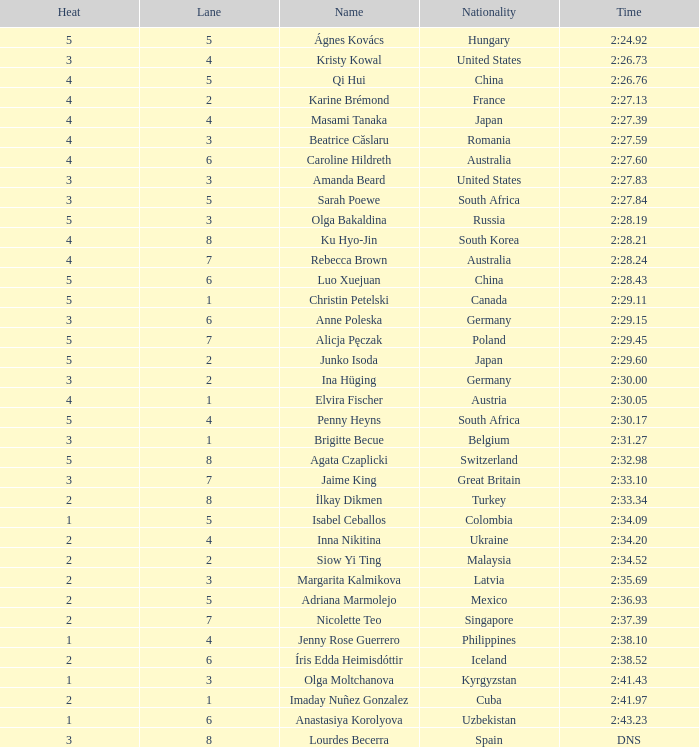Can you give me this table as a dict? {'header': ['Heat', 'Lane', 'Name', 'Nationality', 'Time'], 'rows': [['5', '5', 'Ágnes Kovács', 'Hungary', '2:24.92'], ['3', '4', 'Kristy Kowal', 'United States', '2:26.73'], ['4', '5', 'Qi Hui', 'China', '2:26.76'], ['4', '2', 'Karine Brémond', 'France', '2:27.13'], ['4', '4', 'Masami Tanaka', 'Japan', '2:27.39'], ['4', '3', 'Beatrice Căslaru', 'Romania', '2:27.59'], ['4', '6', 'Caroline Hildreth', 'Australia', '2:27.60'], ['3', '3', 'Amanda Beard', 'United States', '2:27.83'], ['3', '5', 'Sarah Poewe', 'South Africa', '2:27.84'], ['5', '3', 'Olga Bakaldina', 'Russia', '2:28.19'], ['4', '8', 'Ku Hyo-Jin', 'South Korea', '2:28.21'], ['4', '7', 'Rebecca Brown', 'Australia', '2:28.24'], ['5', '6', 'Luo Xuejuan', 'China', '2:28.43'], ['5', '1', 'Christin Petelski', 'Canada', '2:29.11'], ['3', '6', 'Anne Poleska', 'Germany', '2:29.15'], ['5', '7', 'Alicja Pęczak', 'Poland', '2:29.45'], ['5', '2', 'Junko Isoda', 'Japan', '2:29.60'], ['3', '2', 'Ina Hüging', 'Germany', '2:30.00'], ['4', '1', 'Elvira Fischer', 'Austria', '2:30.05'], ['5', '4', 'Penny Heyns', 'South Africa', '2:30.17'], ['3', '1', 'Brigitte Becue', 'Belgium', '2:31.27'], ['5', '8', 'Agata Czaplicki', 'Switzerland', '2:32.98'], ['3', '7', 'Jaime King', 'Great Britain', '2:33.10'], ['2', '8', 'İlkay Dikmen', 'Turkey', '2:33.34'], ['1', '5', 'Isabel Ceballos', 'Colombia', '2:34.09'], ['2', '4', 'Inna Nikitina', 'Ukraine', '2:34.20'], ['2', '2', 'Siow Yi Ting', 'Malaysia', '2:34.52'], ['2', '3', 'Margarita Kalmikova', 'Latvia', '2:35.69'], ['2', '5', 'Adriana Marmolejo', 'Mexico', '2:36.93'], ['2', '7', 'Nicolette Teo', 'Singapore', '2:37.39'], ['1', '4', 'Jenny Rose Guerrero', 'Philippines', '2:38.10'], ['2', '6', 'Íris Edda Heimisdóttir', 'Iceland', '2:38.52'], ['1', '3', 'Olga Moltchanova', 'Kyrgyzstan', '2:41.43'], ['2', '1', 'Imaday Nuñez Gonzalez', 'Cuba', '2:41.97'], ['1', '6', 'Anastasiya Korolyova', 'Uzbekistan', '2:43.23'], ['3', '8', 'Lourdes Becerra', 'Spain', 'DNS']]} What is the name that saw 4 heats and a lane higher than 7? Ku Hyo-Jin. 